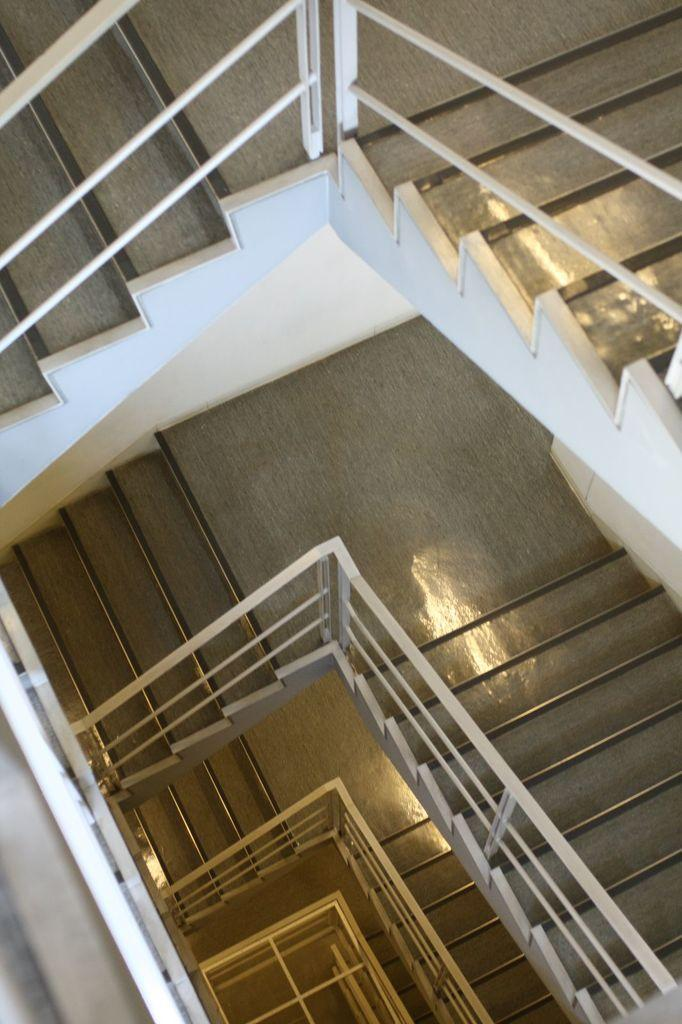What type of structure is present in the image? There is a staircase in the image. How many steps are on the staircase? The staircase has many steps. What part of the staircase can be seen in the image? The floor of the staircase is visible in the image. How does the sand twist around the staircase in the image? There is no sand present in the image, and therefore no sand can twist around the staircase. 